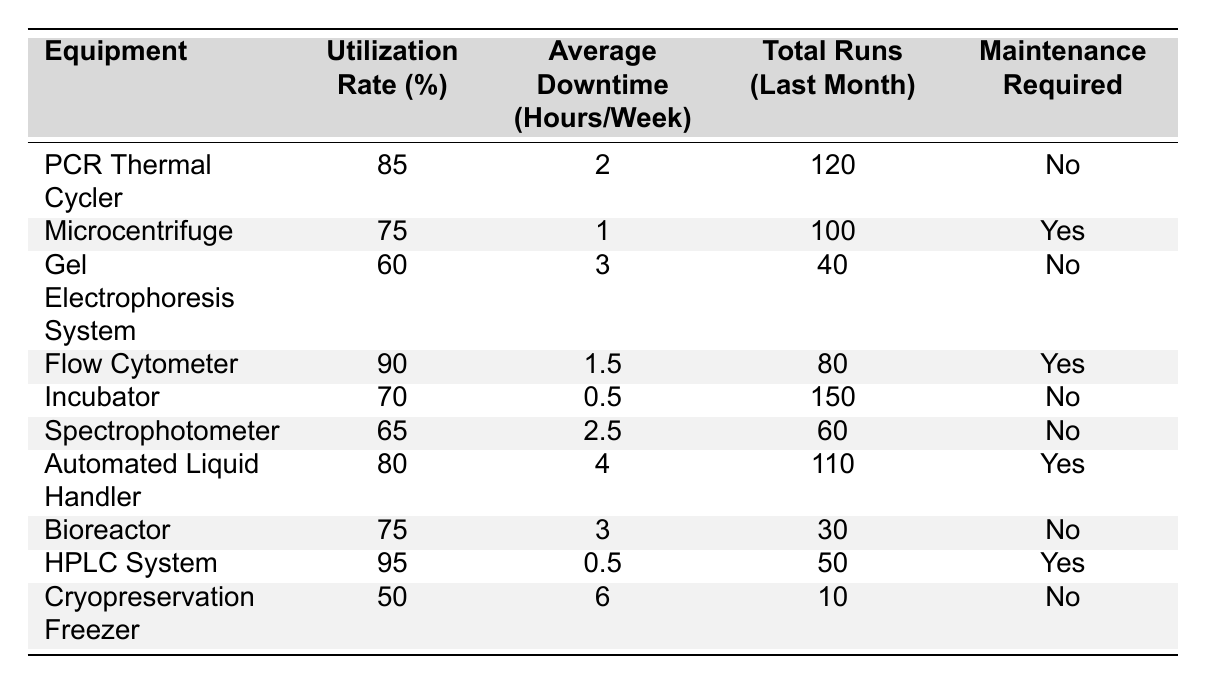What is the utilization rate of the PCR Thermal Cycler? The table indicates that the utilization rate for the PCR Thermal Cycler is listed directly beside the equipment name. Its utilization rate is 85%.
Answer: 85% How many total runs were recorded for the Incubator last month? Looking at the row for the Incubator, the total runs in the last month are explicitly noted, which is 150.
Answer: 150 Which equipment has the highest utilization rate? The table reveals that the HPLC System has the highest utilization rate at 95%.
Answer: HPLC System What is the average downtime for the Microcentrifuge? The average downtime for the Microcentrifuge can be found in its row in the table, which is 1 hour per week.
Answer: 1 hour/week How many pieces of equipment require maintenance? By reviewing the "Maintenance Required" column, three items (Microcentrifuge, Flow Cytometer, and Automated Liquid Handler) indicate "Yes" for maintenance required, so there are three pieces of equipment.
Answer: 3 What is the total average downtime of all equipment listed? To find the total average downtime, sum the average downtimes of each piece of equipment: (2 + 1 + 3 + 1.5 + 0.5 + 2.5 + 4 + 3 + 0.5 + 6) = 24. The number of pieces of equipment is 10. Therefore, the total average downtime is 24/10 = 2.4 hours per week.
Answer: 2.4 hours/week Is the equipment with the lowest utilization rate the Cryopreservation Freezer? The Cryopreservation Freezer has a utilization rate of 50%, which is the lowest compared to other pieces of equipment listed (the next lowest is Gel Electrophoresis System at 60%). Thus, this statement is true.
Answer: Yes What is the difference in utilization rates between the Flow Cytometer and the Spectrophotometer? The utilization rate for the Flow Cytometer is 90%, while the Spectrophotometer is at 65%. The difference is calculated by subtracting 65 from 90, giving us 25%.
Answer: 25% Which piece of equipment has the highest average downtime, and what is that value? The highest average downtime is found in the Cryopreservation Freezer, which has an average downtime of 6 hours per week.
Answer: Cryopreservation Freezer, 6 hours/week What is the total number of runs for all equipment combined from last month? Adding the total runs from each piece of equipment gives us: 120 + 100 + 40 + 80 + 150 + 60 + 110 + 30 + 50 + 10 = 800.
Answer: 800 runs 